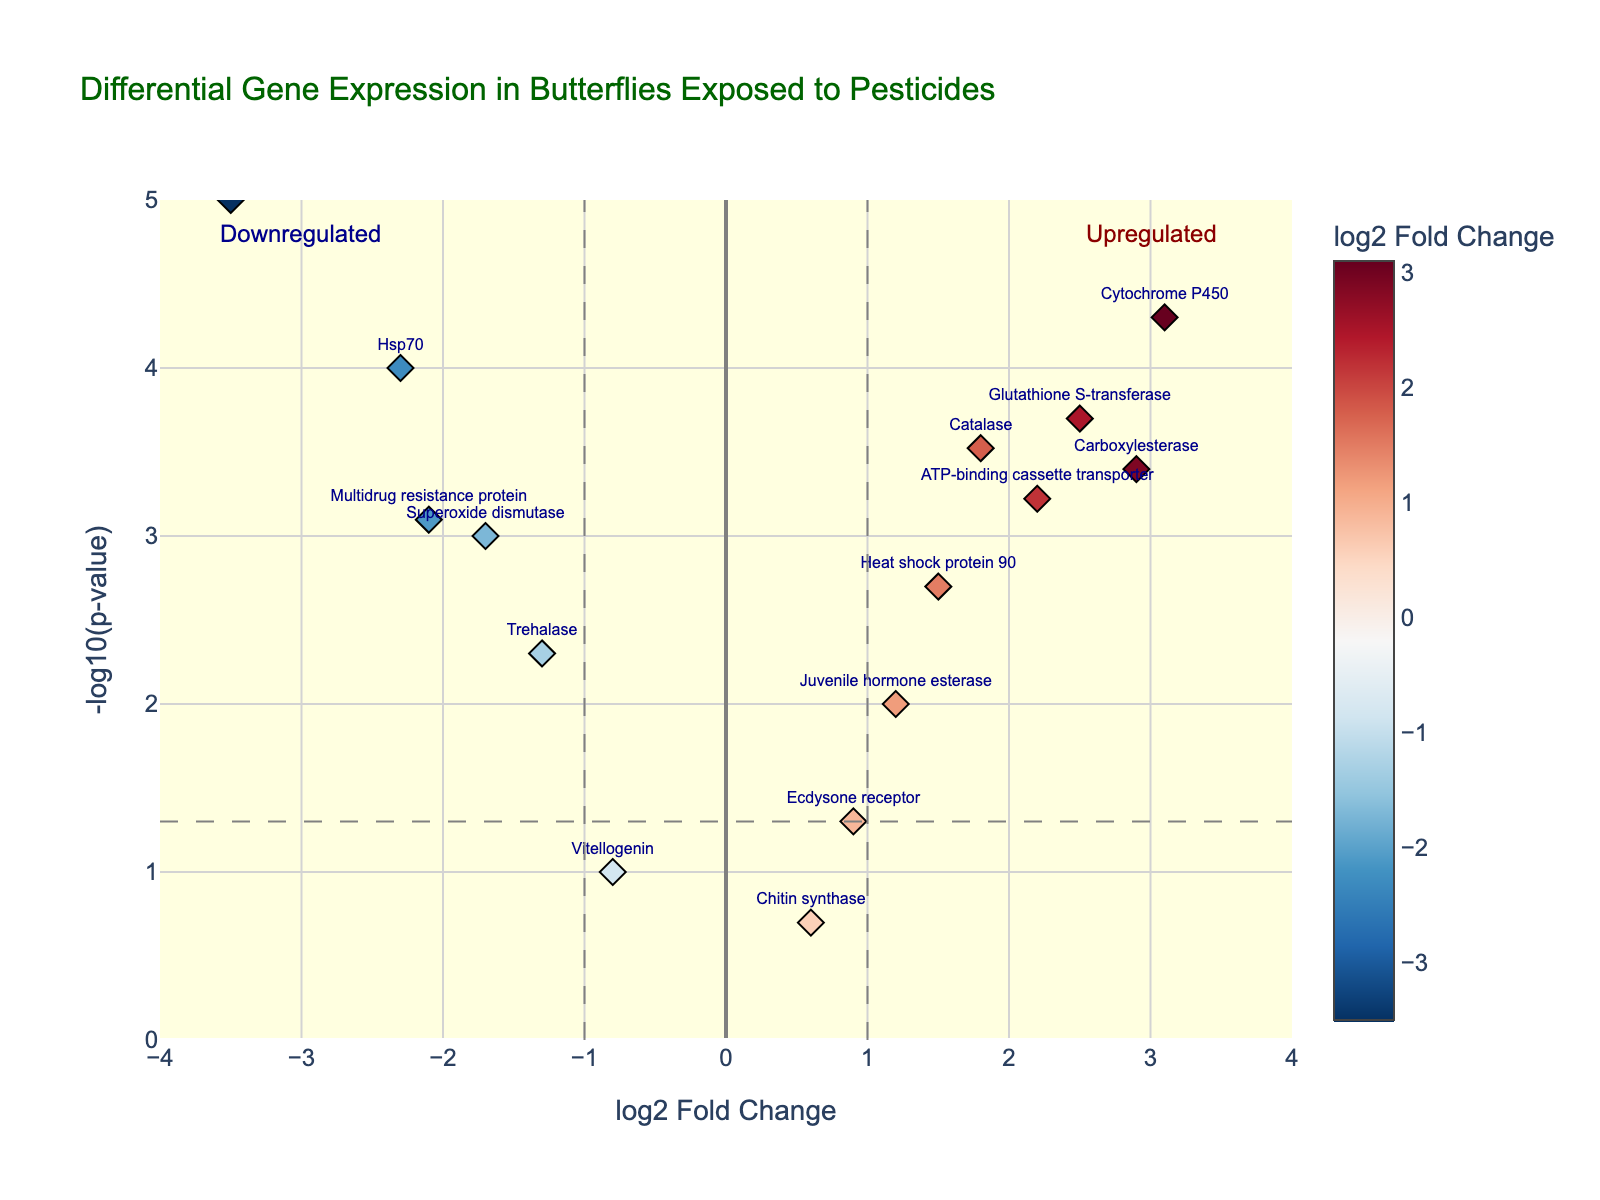Which gene has the highest -log10(p-value)? The highest -log10(p-value) is the point at the top of the plot. This corresponds to "Cytochrome P450".
Answer: Cytochrome P450 What are the x-axis and y-axis representing in this plot? The x-axis represents the log2 Fold Change, indicating gene expression change levels. The y-axis represents -log10(p-value), indicating the significance of these changes.
Answer: log2 Fold Change and -log10(p-value) Which gene shows the greatest downregulation? The gene with the lowest log2 Fold Change value indicates the greatest downregulation. The lowest log2 Fold Change is for "Acetylcholinesterase", which has a value of -3.5.
Answer: Acetylcholinesterase How many genes are significantly upregulated according to this plot? Significant upregulation occurs for points with log2 Fold Change > 1 and -log10(p-value) > 1.301. By examining the plot, genes like Catalase, Cytochrome P450, Glutathione S-transferase, Carboxylesterase, Heat shock protein 90, and ATP-binding cassette transporter meet these criteria.
Answer: 6 Which genes have a log2 Fold Change greater than 2? These are the genes plotted to the right of x = 2. The genes are Cytochrome P450, Glutathione S-transferase, and Carboxylesterase.
Answer: Cytochrome P450, Glutathione S-transferase, Carboxylesterase Is Vitellogenin significantly differentially expressed? A gene is significantly differentially expressed if its -log10(p-value) > 1.301. Vitellogenin has a -log10(p-value) below this threshold, hence it is not significantly differentially expressed.
Answer: No Compare the expression of Superoxide dismutase and Multidrug resistance protein, which is more downregulated? The gene with a more negative log2 Fold Change is more downregulated. Superoxide dismutase has a log2 Fold Change of -1.7, and Multidrug resistance protein has -2.1. Therefore, Multidrug resistance protein is more downregulated.
Answer: Multidrug resistance protein What visual cues are used to indicate significance thresholds in the plot? The plot uses grey dashed lines to indicate significance thresholds. These are a horizontal line at -log10(p-value)=1.301 and vertical lines at log2 Fold Change of -1 and 1.
Answer: Grey dashed lines 